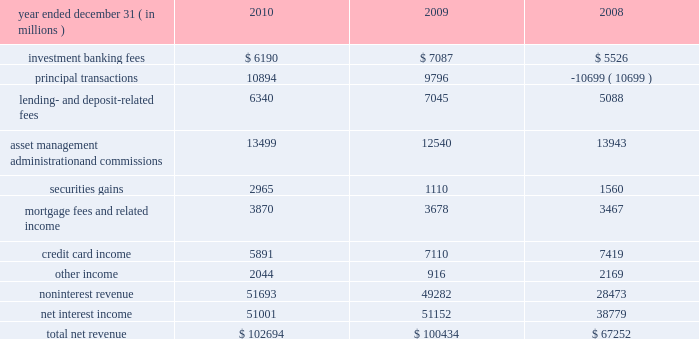Jpmorgan chase & co./2010 annual report 59 consolidated results of operations this following section provides a comparative discussion of jpmorgan chase 2019s consolidated results of operations on a reported basis for the three-year period ended december 31 , 2010 .
Factors that related primarily to a single business segment are discussed in more detail within that business segment .
For a discussion of the critical accounting estimates used by the firm that affect the consolidated results of operations , see pages 149 2013 154 of this annual report .
Revenue year ended december 31 , ( in millions ) 2010 2009 2008 .
2010 compared with 2009 total net revenue for 2010 was $ 102.7 billion , up by $ 2.3 billion , or 2% ( 2 % ) , from 2009 .
Results for 2010 were driven by a higher level of securities gains and private equity gains in corporate/private equity , higher asset management fees in am and administration fees in tss , and higher other income in several businesses , partially offset by lower credit card income .
Investment banking fees decreased from 2009 due to lower equity underwriting and advisory fees , partially offset by higher debt underwriting fees .
Competitive markets combined with flat industry-wide equity underwriting and completed m&a volumes , resulted in lower equity underwriting and advisory fees ; while strong industry-wide loan syndication and high-yield bond volumes drove record debt underwriting fees in ib .
For additional information on investment banking fees , which are primarily recorded in ib , see ib segment results on pages 69 201371 of this annual report .
Principal transactions revenue , which consists of revenue from the firm 2019s trading and private equity investing activities , increased compared with 2009 .
This was driven by the private equity business , which had significant private equity gains in 2010 , compared with a small loss in 2009 , reflecting improvements in market conditions .
Trading revenue decreased , reflecting lower results in corporate , offset by higher revenue in ib primarily reflecting gains from the widening of the firm 2019s credit spread on certain structured and derivative liabilities .
For additional information on principal transactions revenue , see ib and corporate/private equity segment results on pages 69 201371 and 89 2013 90 , respectively , and note 7 on pages 199 2013200 of this annual report .
Lending- and deposit-related fees decreased in 2010 from 2009 levels , reflecting lower deposit-related fees in rfs associated , in part , with newly-enacted legislation related to non-sufficient funds and overdraft fees ; this was partially offset by higher lending- related service fees in ib , primarily from growth in business volume , and in cb , primarily from higher commitment and letter-of-credit fees .
For additional information on lending- and deposit-related fees , which are mostly recorded in ib , rfs , cb and tss , see segment results for ib on pages 69 201371 , rfs on pages 72 201378 , cb on pages 82 201383 and tss on pages 84 201385 of this annual report .
Asset management , administration and commissions revenue increased from 2009 .
The increase largely reflected higher asset management fees in am , driven by the effect of higher market levels , net inflows to products with higher margins and higher performance fees ; and higher administration fees in tss , reflecting the effects of higher market levels and net inflows of assets under custody .
This increase was partially offset by lower brokerage commissions in ib , as a result of lower market volumes .
For additional information on these fees and commissions , see the segment discussions for am on pages 86 201388 and tss on pages 84 201385 of this annual report .
Securities gains were significantly higher in 2010 compared with 2009 , resulting primarily from the repositioning of the portfolio in response to changes in the interest rate environment and to rebalance exposure .
For additional information on securities gains , which are mostly recorded in the firm 2019s corporate segment , see the corporate/private equity segment discussion on pages 89 201390 of this annual report .
Mortgage fees and related income increased in 2010 compared with 2009 , driven by higher mortgage production revenue , reflecting increased mortgage origination volumes in rfs and am , and wider margins , particularly in rfs .
This increase was largely offset by higher repurchase losses in rfs ( recorded as contra- revenue ) , which were attributable to higher estimated losses related to repurchase demands , predominantly from gses .
For additional information on mortgage fees and related income , which is recorded primarily in rfs , see rfs 2019s mortgage banking , auto & other consumer lending discussion on pages 74 201377 of this annual report .
For additional information on repurchase losses , see the repurchase liability discussion on pages 98 2013101 and note 30 on pages 275 2013280 of this annual report .
Credit card income decreased during 2010 , predominantly due to the impact of the accounting guidance related to vies , effective january 1 , 2010 , that required the firm to consolidate the assets and liabilities of its firm-sponsored credit card securitization trusts .
Adoption of the new guidance resulted in the elimination of all servicing fees received from firm-sponsored credit card securitization trusts ( which was offset by related increases in net .
What was noninterest revenue as a percent of total net revenue in 2009? 
Computations: (49282 / 100434)
Answer: 0.49069. 